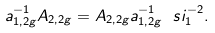<formula> <loc_0><loc_0><loc_500><loc_500>a _ { 1 , 2 g } ^ { - 1 } A _ { 2 , 2 g } = A _ { 2 , 2 g } a _ { 1 , 2 g } ^ { - 1 } \ s i _ { 1 } ^ { - 2 } .</formula> 